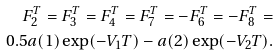<formula> <loc_0><loc_0><loc_500><loc_500>F ^ { T } _ { 2 } = F ^ { T } _ { 3 } = F ^ { T } _ { 4 } = F ^ { T } _ { 7 } = - F ^ { T } _ { 6 } = - F ^ { T } _ { 8 } = \\ 0 . 5 a ( 1 ) \exp ( - V _ { 1 } T ) - a ( 2 ) \exp ( - V _ { 2 } T ) .</formula> 